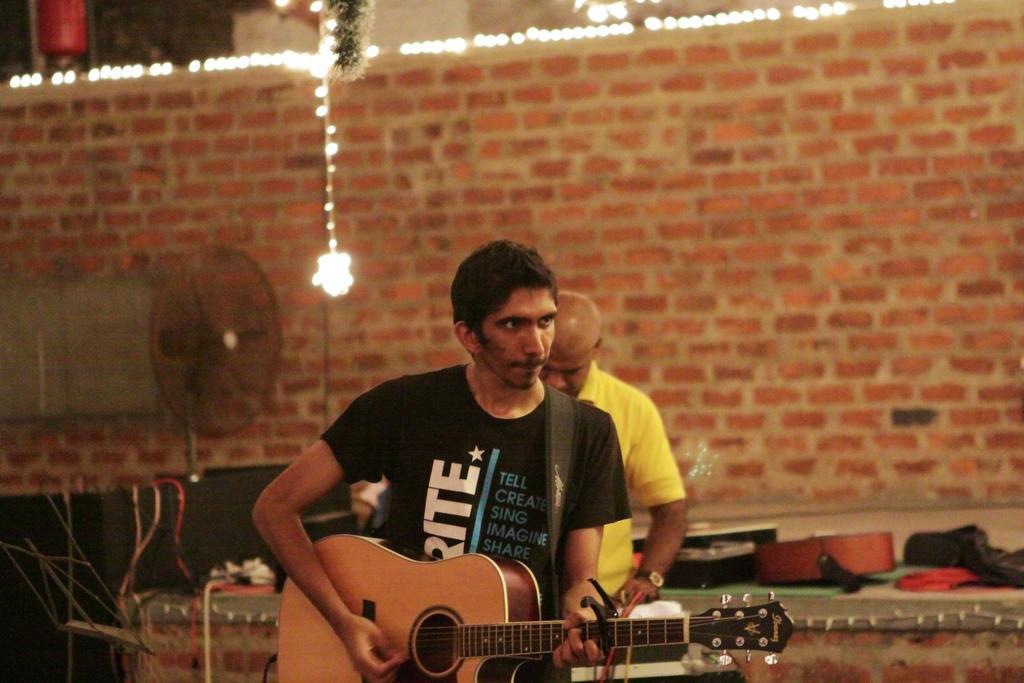Could you give a brief overview of what you see in this image? In this image a man wearing black t-shirt is playing guitar. Behind him another person is standing. On the stage there are many instruments. There is a stand fan here. In the background there is wall and lights. 